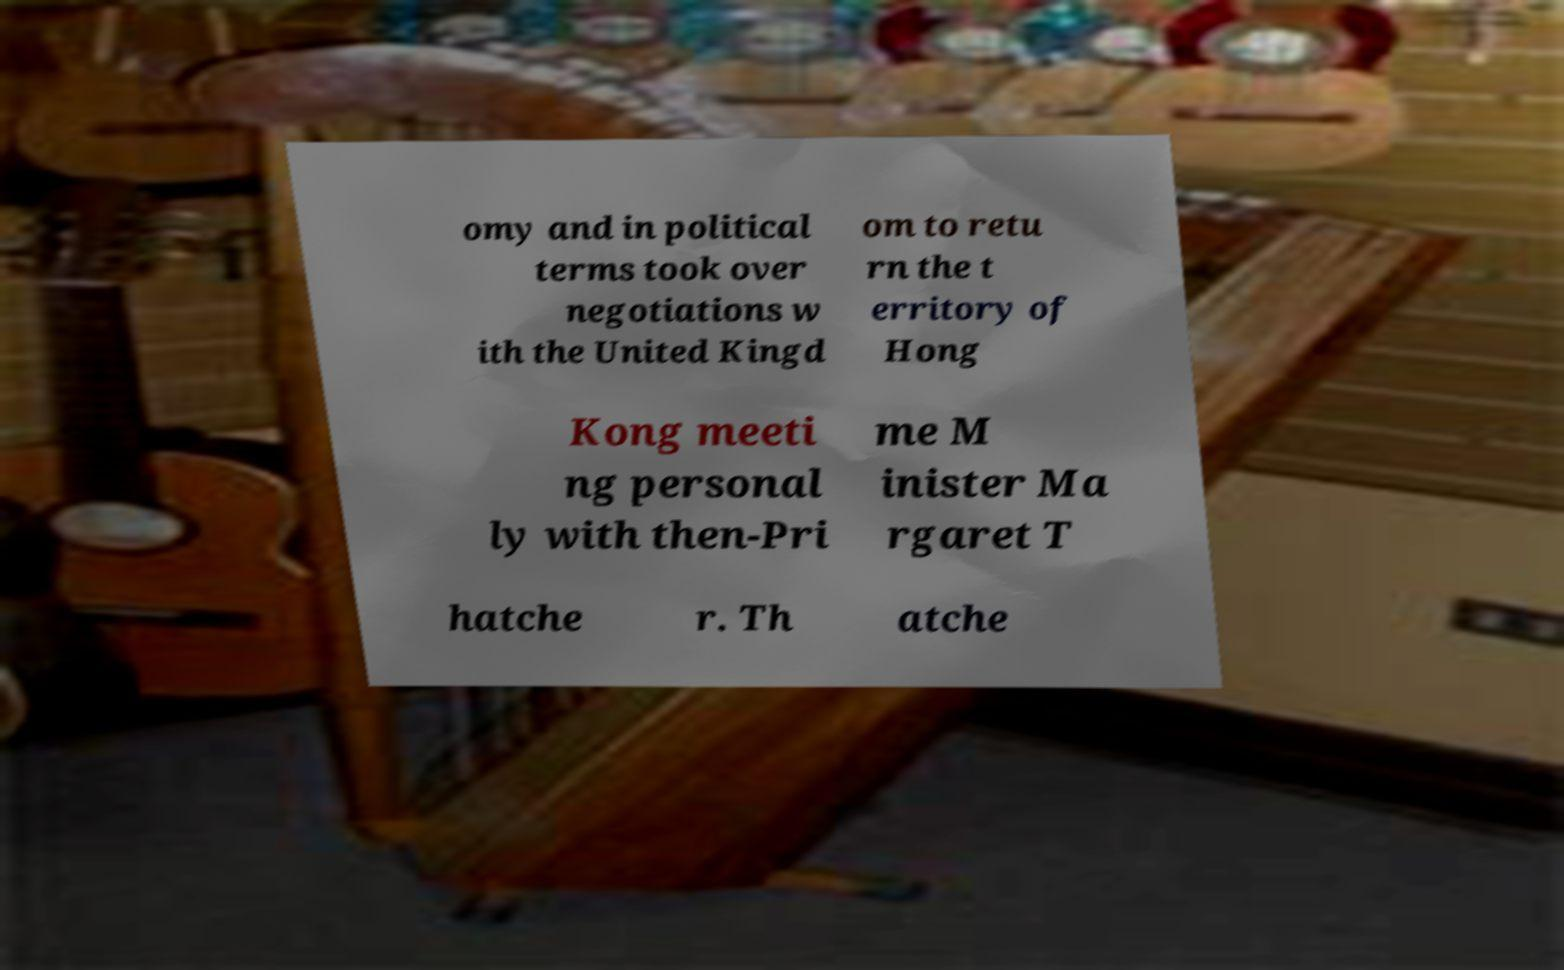I need the written content from this picture converted into text. Can you do that? omy and in political terms took over negotiations w ith the United Kingd om to retu rn the t erritory of Hong Kong meeti ng personal ly with then-Pri me M inister Ma rgaret T hatche r. Th atche 